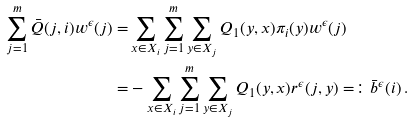<formula> <loc_0><loc_0><loc_500><loc_500>\sum _ { j = 1 } ^ { m } \bar { Q } ( j , i ) w ^ { \epsilon } ( j ) = & \sum _ { x \in X _ { i } } \sum _ { j = 1 } ^ { m } \sum _ { y \in X _ { j } } Q _ { 1 } ( y , x ) \pi _ { i } ( y ) w ^ { \epsilon } ( j ) \\ = & - \sum _ { x \in X _ { i } } \sum _ { j = 1 } ^ { m } \sum _ { y \in X _ { j } } Q _ { 1 } ( y , x ) r ^ { \epsilon } ( j , y ) = \colon \bar { b } ^ { \epsilon } ( i ) \, .</formula> 